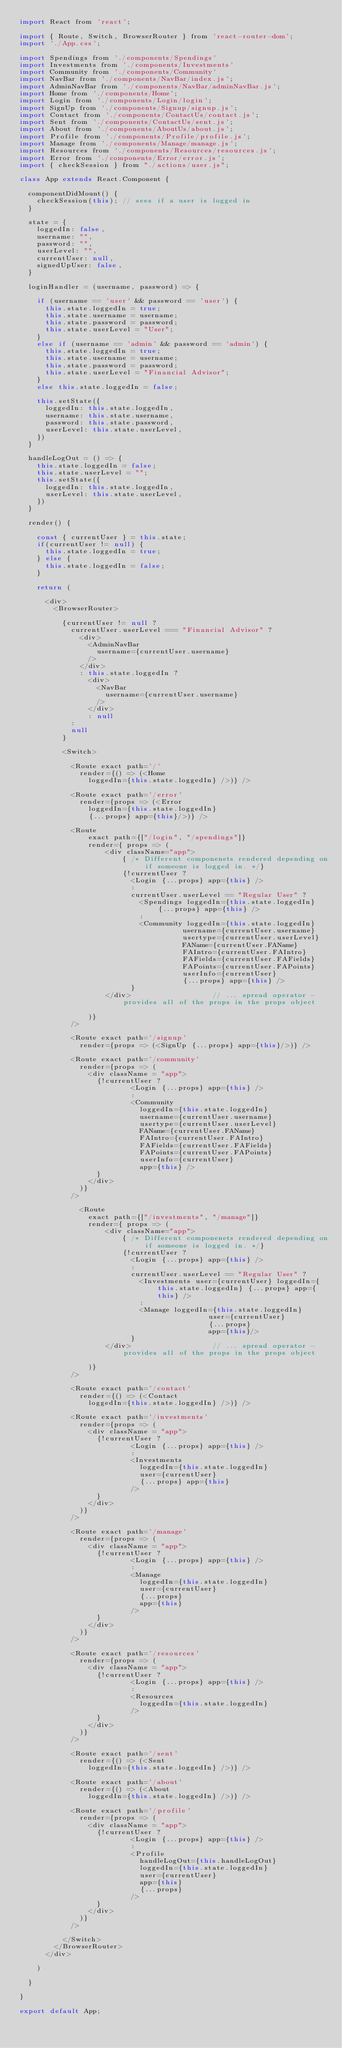Convert code to text. <code><loc_0><loc_0><loc_500><loc_500><_JavaScript_>import React from 'react';

import { Route, Switch, BrowserRouter } from 'react-router-dom';
import './App.css';

import Spendings from './components/Spendings'
import Investments from './components/Investments'
import Community from './components/Community'
import NavBar from './components/NavBar/index.js';
import AdminNavBar from './components/NavBar/adminNavBar.js';
import Home from './components/Home';
import Login from './components/Login/login';
import SignUp from './components/Signup/signup.js';
import Contact from './components/ContactUs/contact.js';
import Sent from './components/ContactUs/sent.js';
import About from './components/AboutUs/about.js';
import Profile from './components/Profile/profile.js';
import Manage from './components/Manage/manage.js';
import Resources from './components/Resources/resources.js';
import Error from './components/Error/error.js';
import { checkSession } from "./actions/user.js";

class App extends React.Component {

  componentDidMount() {
    checkSession(this); // sees if a user is logged in
  }

  state = {
    loggedIn: false,
    username: "",
    password: "",
    userLevel: "",
    currentUser: null,
    signedUpUser: false,
  }

  loginHandler = (username, password) => {

    if (username == 'user' && password == 'user') {
      this.state.loggedIn = true;
      this.state.username = username;
      this.state.password = password;
      this.state.userLevel = "User";
    }
    else if (username == 'admin' && password == 'admin') {
      this.state.loggedIn = true;
      this.state.username = username;
      this.state.password = password;
      this.state.userLevel = "Financial Advisor";
    }
    else this.state.loggedIn = false;

    this.setState({
      loggedIn: this.state.loggedIn,
      username: this.state.username,
      password: this.state.password,
      userLevel: this.state.userLevel,
    })
  }

  handleLogOut = () => {
    this.state.loggedIn = false;
    this.state.userLevel = "";
    this.setState({
      loggedIn: this.state.loggedIn,
      userLevel: this.state.userLevel,
    })
  }

  render() {

    const { currentUser } = this.state;
    if(currentUser != null) {
      this.state.loggedIn = true;
    } else {
      this.state.loggedIn = false;
    }

    return (

      <div>
        <BrowserRouter>

          {currentUser != null ? 
            currentUser.userLevel === "Financial Advisor" ?
              <div>
                <AdminNavBar
                  username={currentUser.username}
                />
              </div>
              : this.state.loggedIn ?
                <div>
                  <NavBar
                    username={currentUser.username}
                  />
                </div>
                : null
            :
            null
          }

          <Switch>

            <Route exact path='/'
              render={() => (<Home
                loggedIn={this.state.loggedIn} />)} />

            <Route exact path='/error'
              render={props => (<Error 
                loggedIn={this.state.loggedIn}
                {...props} app={this}/>)} />
            
            <Route
                exact path={["/login", "/spendings"]}
                render={ props => (
                    <div className="app">
                        { /* Different componenets rendered depending on if someone is logged in. */}
                        {!currentUser ? 
                          <Login {...props} app={this} /> 
                          : 
                          currentUser.userLevel == "Regular User" ?
                            <Spendings loggedIn={this.state.loggedIn} {...props} app={this} />
                            :
                            <Community loggedIn={this.state.loggedIn}
                                      username={currentUser.username}
                                      usertype={currentUser.userLevel}
                                      FAName={currentUser.FAName}
                                      FAIntro={currentUser.FAIntro}
                                      FAFields={currentUser.FAFields}
                                      FAPoints={currentUser.FAPoints}
                                      userInfo={currentUser}
                                      {...props} app={this} />
                          }
                    </div>                   // ... spread operator - provides all of the props in the props object
                    
                )}
            />

            <Route exact path='/signup'
              render={props => (<SignUp {...props} app={this}/>)} />

            <Route exact path='/community'
              render={props => (
                <div className = "app">
                  {!currentUser ? 
                          <Login {...props} app={this} /> 
                          : 
                          <Community
                            loggedIn={this.state.loggedIn}
                            username={currentUser.username}
                            usertype={currentUser.userLevel}
                            FAName={currentUser.FAName}
                            FAIntro={currentUser.FAIntro}
                            FAFields={currentUser.FAFields}
                            FAPoints={currentUser.FAPoints}
                            userInfo={currentUser}
                            app={this} />
                  }
                </div>
              )}
            />

              <Route
                exact path={["/investments", "/manage"]}
                render={ props => (
                    <div className="app">
                        { /* Different componenets rendered depending on if someone is logged in. */}
                        {!currentUser ? 
                          <Login {...props} app={this} /> 
                          : 
                          currentUser.userLevel == "Regular User" ?
                            <Investments user={currentUser} loggedIn={this.state.loggedIn} {...props} app={this} />
                            :
                            <Manage loggedIn={this.state.loggedIn}
                                            user={currentUser}
                                            {...props} 
                                            app={this}/>
                          }
                    </div>                   // ... spread operator - provides all of the props in the props object
                    
                )}
            />

            <Route exact path='/contact'
              render={() => (<Contact
                loggedIn={this.state.loggedIn} />)} />

            <Route exact path='/investments'
              render={props => (
                <div className = "app">
                  {!currentUser ? 
                          <Login {...props} app={this} /> 
                          : 
                          <Investments
                            loggedIn={this.state.loggedIn}
                            user={currentUser}
                            {...props} app={this}
                          />
                  }
                </div>
              )}
            />

            <Route exact path='/manage'
              render={props => (
                <div className = "app">
                  {!currentUser ? 
                          <Login {...props} app={this} /> 
                          : 
                          <Manage
                            loggedIn={this.state.loggedIn}
                            user={currentUser}
                            {...props} 
                            app={this}
                          />
                  }
                </div>
              )}
            />

            <Route exact path='/resources'
              render={props => (
                <div className = "app">
                  {!currentUser ? 
                          <Login {...props} app={this} /> 
                          : 
                          <Resources
                            loggedIn={this.state.loggedIn}
                          />
                  }
                </div>
              )}
            />

            <Route exact path='/sent'
              render={() => (<Sent
                loggedIn={this.state.loggedIn} />)} />

            <Route exact path='/about'
              render={() => (<About
                loggedIn={this.state.loggedIn} />)} />

            <Route exact path='/profile'
              render={props => (
                <div className = "app">
                  {!currentUser ? 
                          <Login {...props} app={this} /> 
                          : 
                          <Profile
                            handleLogOut={this.handleLogOut}
                            loggedIn={this.state.loggedIn}
                            user={currentUser}
                            app={this}
                            {...props}
                          />
                  }
                </div>
              )}
            />

          </Switch>
        </BrowserRouter>
      </div>

    )

  }

}

export default App;</code> 